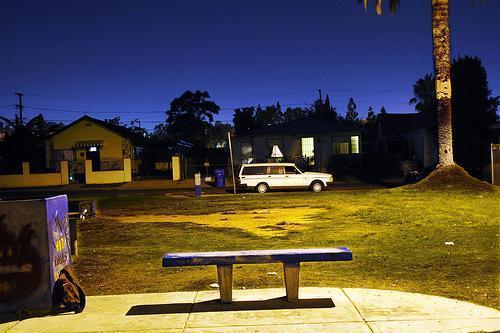How many vehicles are in the picture?
Give a very brief answer. 1. 